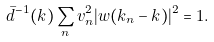Convert formula to latex. <formula><loc_0><loc_0><loc_500><loc_500>\bar { d } ^ { - 1 } ( k ) \sum _ { n } v _ { n } ^ { 2 } | w ( k _ { n } - k ) | ^ { 2 } = 1 .</formula> 